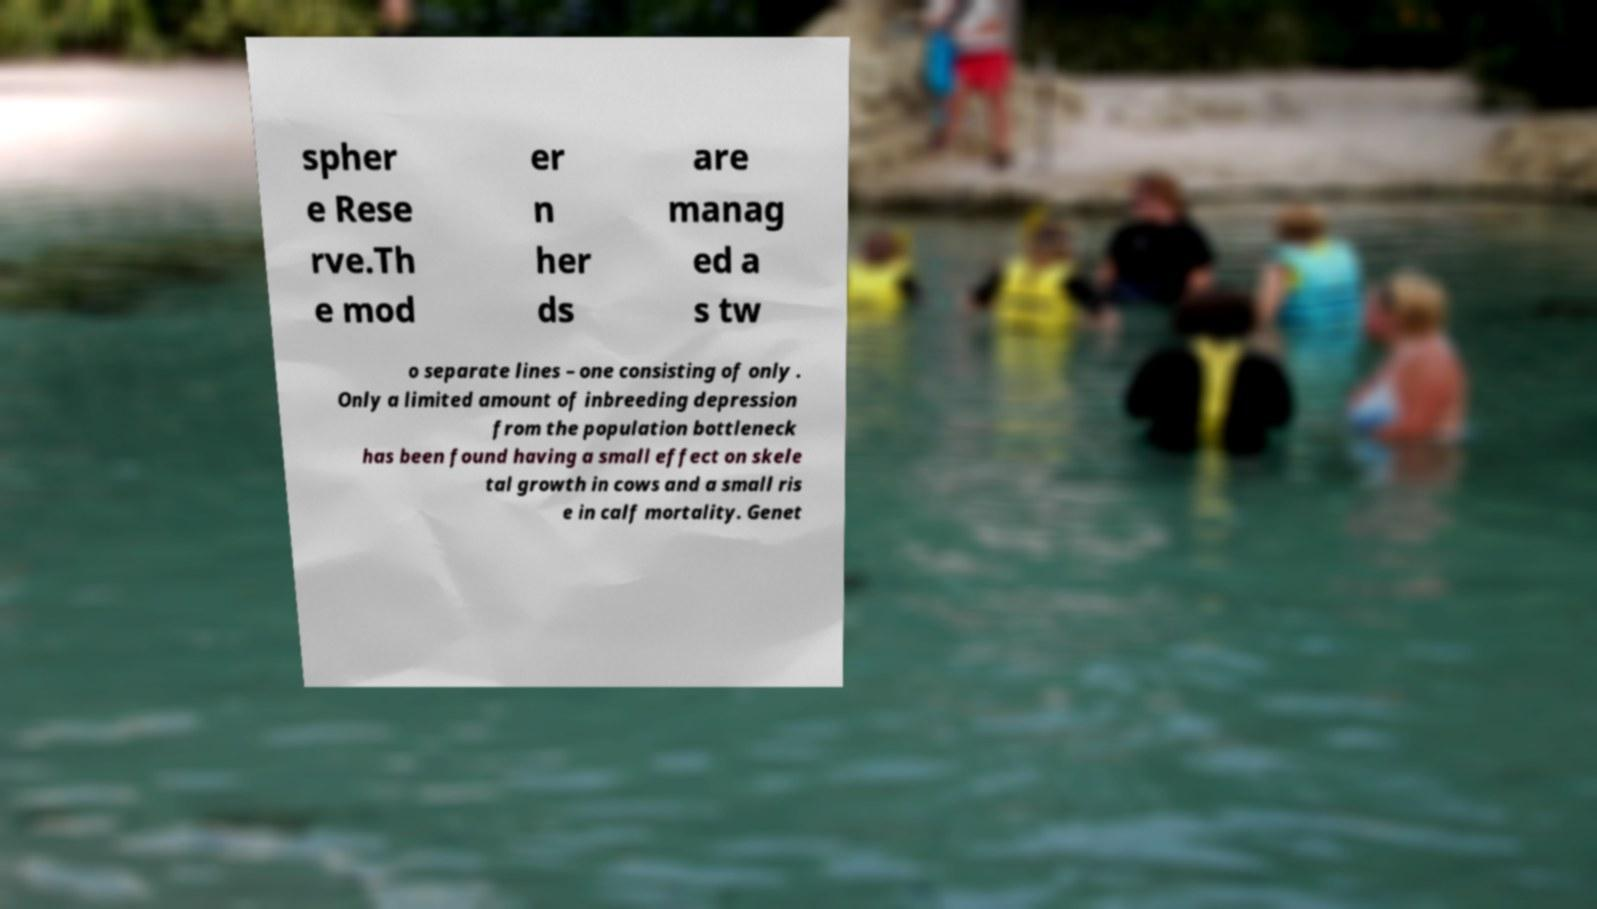Can you accurately transcribe the text from the provided image for me? spher e Rese rve.Th e mod er n her ds are manag ed a s tw o separate lines – one consisting of only . Only a limited amount of inbreeding depression from the population bottleneck has been found having a small effect on skele tal growth in cows and a small ris e in calf mortality. Genet 